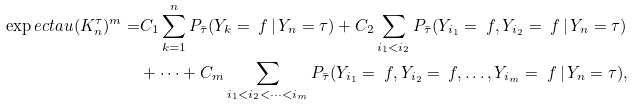Convert formula to latex. <formula><loc_0><loc_0><loc_500><loc_500>\exp e c t a u { ( K _ { n } ^ { \tau } ) ^ { m } } = & C _ { 1 } \sum _ { k = 1 } ^ { n } P _ { \bar { \tau } } ( Y _ { k } = \ f \, | \, Y _ { n } = \tau ) + C _ { 2 } \sum _ { i _ { 1 } < i _ { 2 } } P _ { \bar { \tau } } ( Y _ { i _ { 1 } } = \ f , Y _ { i _ { 2 } } = \ f \, | \, Y _ { n } = \tau ) \\ & + \cdots + C _ { m } \sum _ { i _ { 1 } < i _ { 2 } < \dots < i _ { m } } P _ { \bar { \tau } } ( Y _ { i _ { 1 } } = \ f , Y _ { i _ { 2 } } = \ f , \dots , Y _ { i _ { m } } = \ f \, | \, Y _ { n } = \tau ) ,</formula> 